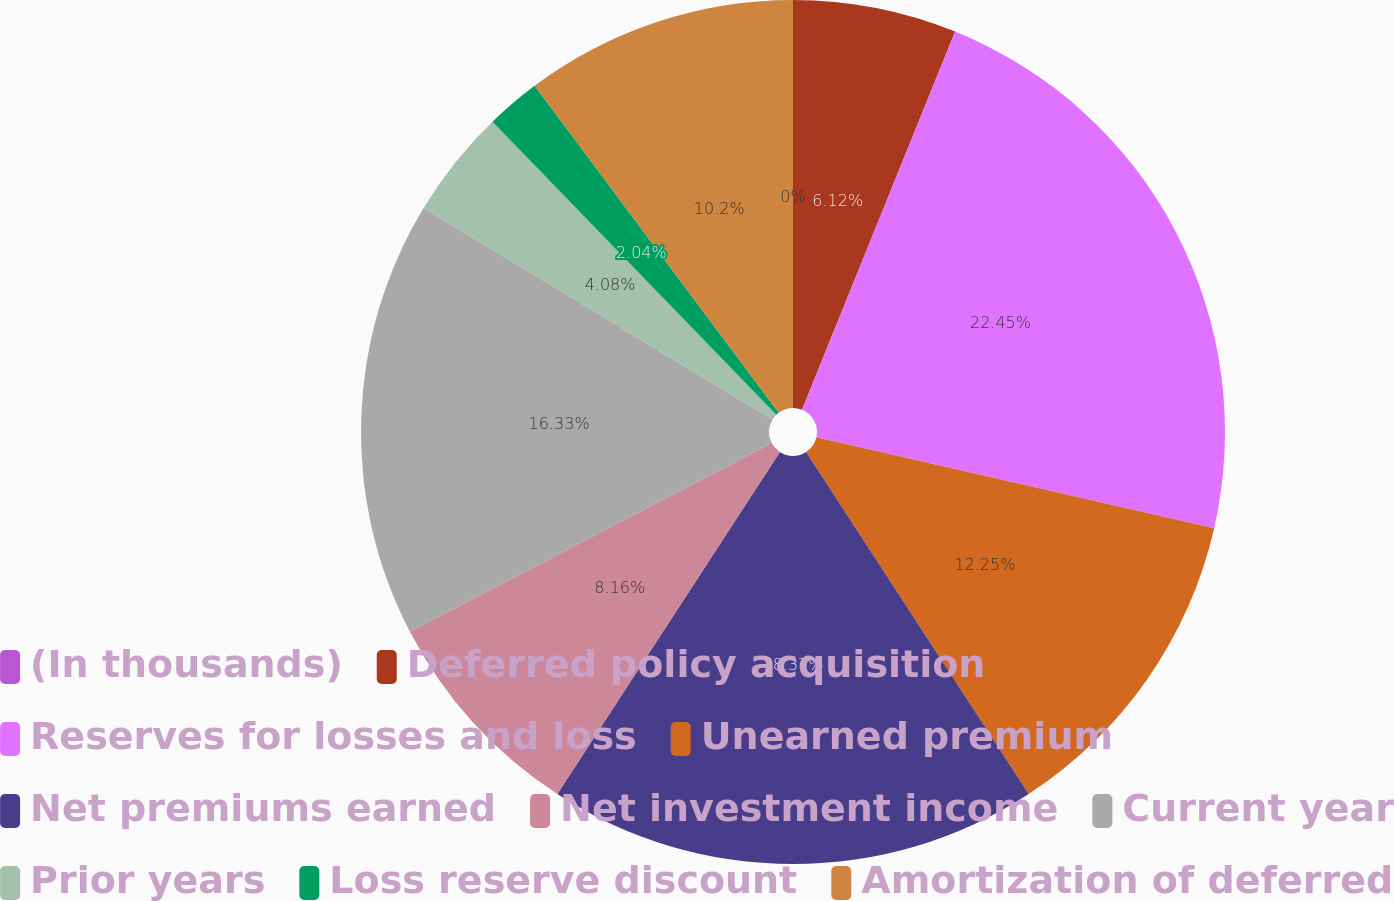Convert chart. <chart><loc_0><loc_0><loc_500><loc_500><pie_chart><fcel>(In thousands)<fcel>Deferred policy acquisition<fcel>Reserves for losses and loss<fcel>Unearned premium<fcel>Net premiums earned<fcel>Net investment income<fcel>Current year<fcel>Prior years<fcel>Loss reserve discount<fcel>Amortization of deferred<nl><fcel>0.0%<fcel>6.12%<fcel>22.44%<fcel>12.24%<fcel>18.36%<fcel>8.16%<fcel>16.32%<fcel>4.08%<fcel>2.04%<fcel>10.2%<nl></chart> 